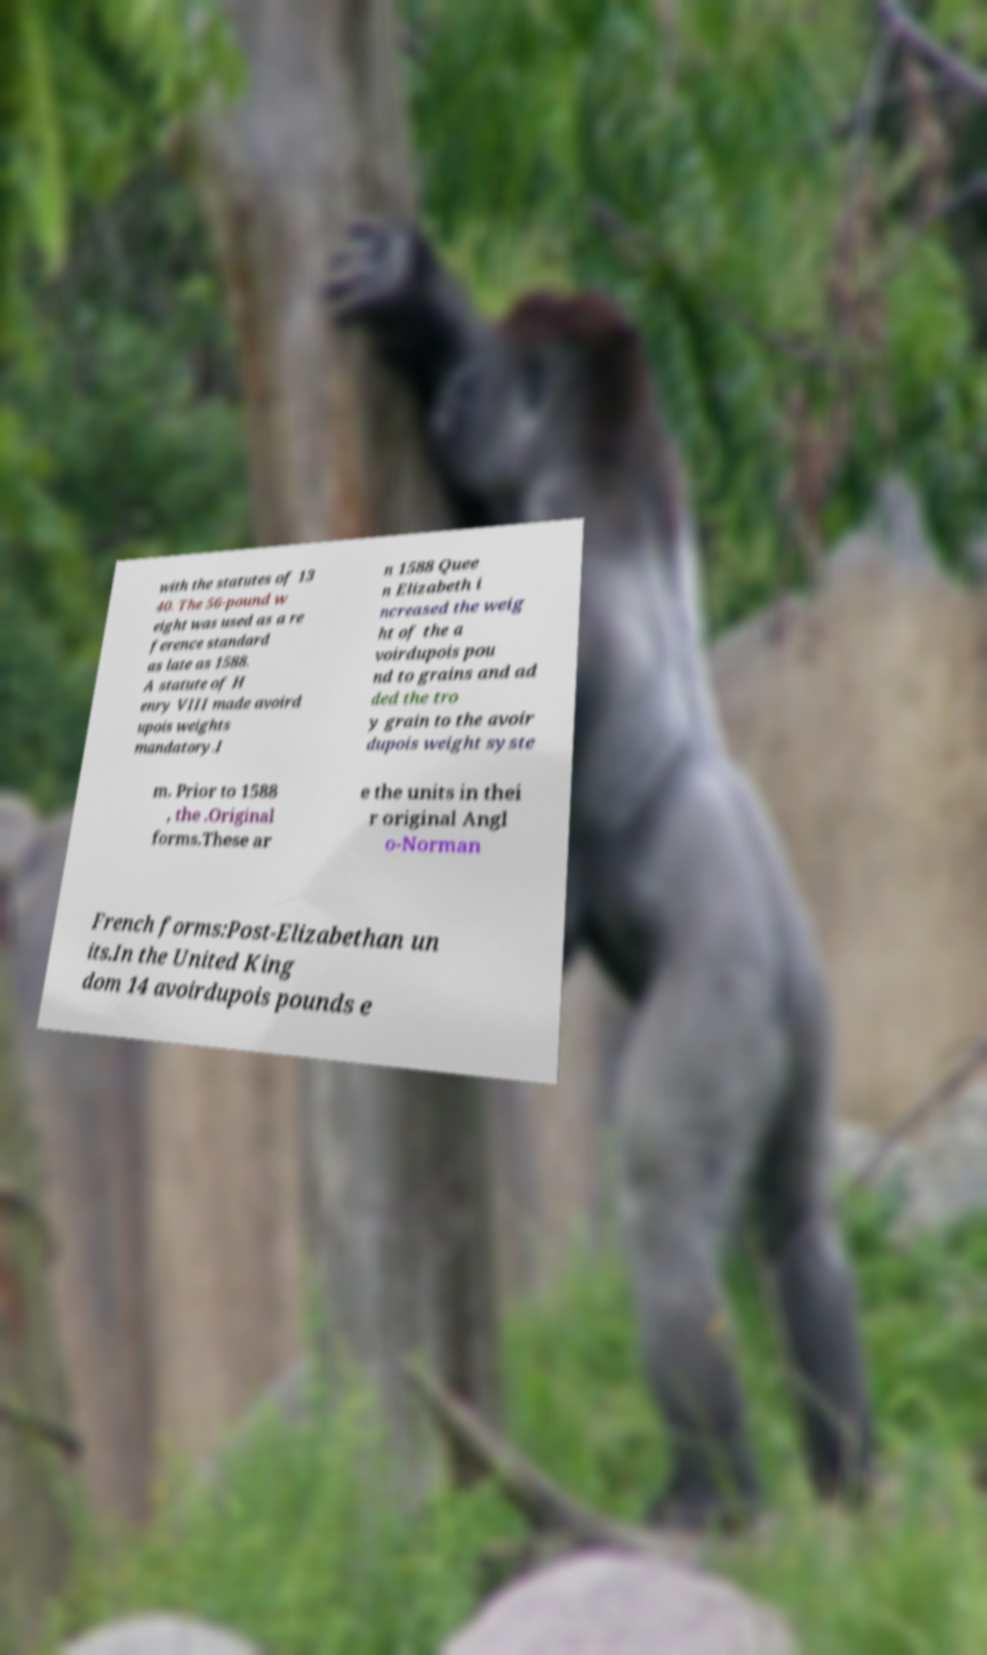For documentation purposes, I need the text within this image transcribed. Could you provide that? with the statutes of 13 40. The 56-pound w eight was used as a re ference standard as late as 1588. A statute of H enry VIII made avoird upois weights mandatory.I n 1588 Quee n Elizabeth i ncreased the weig ht of the a voirdupois pou nd to grains and ad ded the tro y grain to the avoir dupois weight syste m. Prior to 1588 , the .Original forms.These ar e the units in thei r original Angl o-Norman French forms:Post-Elizabethan un its.In the United King dom 14 avoirdupois pounds e 